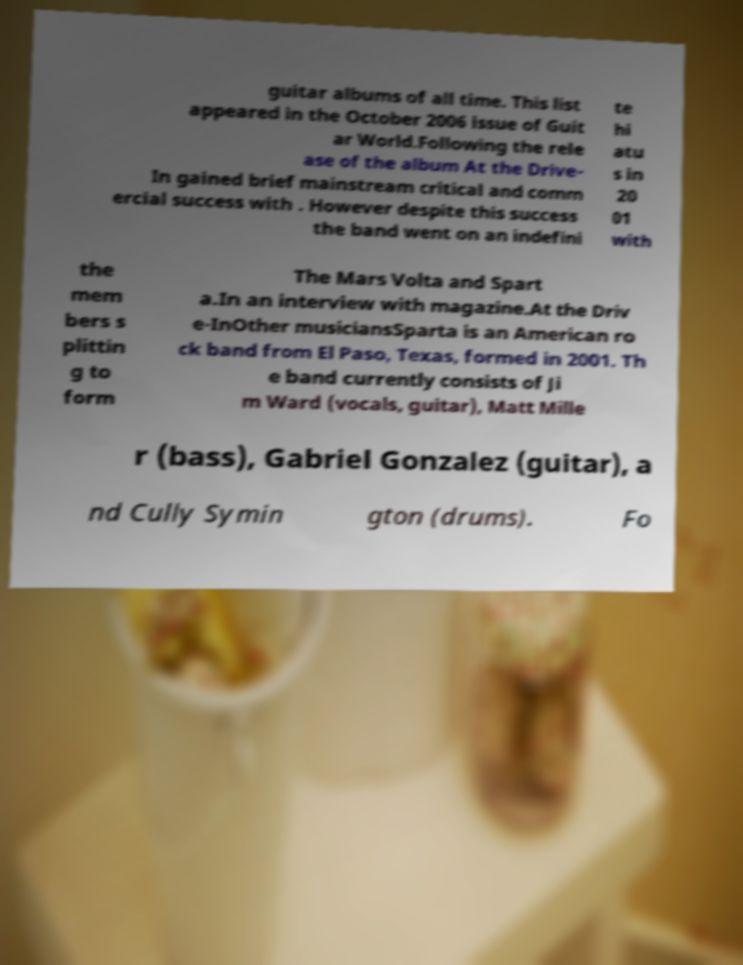Could you assist in decoding the text presented in this image and type it out clearly? guitar albums of all time. This list appeared in the October 2006 issue of Guit ar World.Following the rele ase of the album At the Drive- In gained brief mainstream critical and comm ercial success with . However despite this success the band went on an indefini te hi atu s in 20 01 with the mem bers s plittin g to form The Mars Volta and Spart a.In an interview with magazine.At the Driv e-InOther musiciansSparta is an American ro ck band from El Paso, Texas, formed in 2001. Th e band currently consists of Ji m Ward (vocals, guitar), Matt Mille r (bass), Gabriel Gonzalez (guitar), a nd Cully Symin gton (drums). Fo 